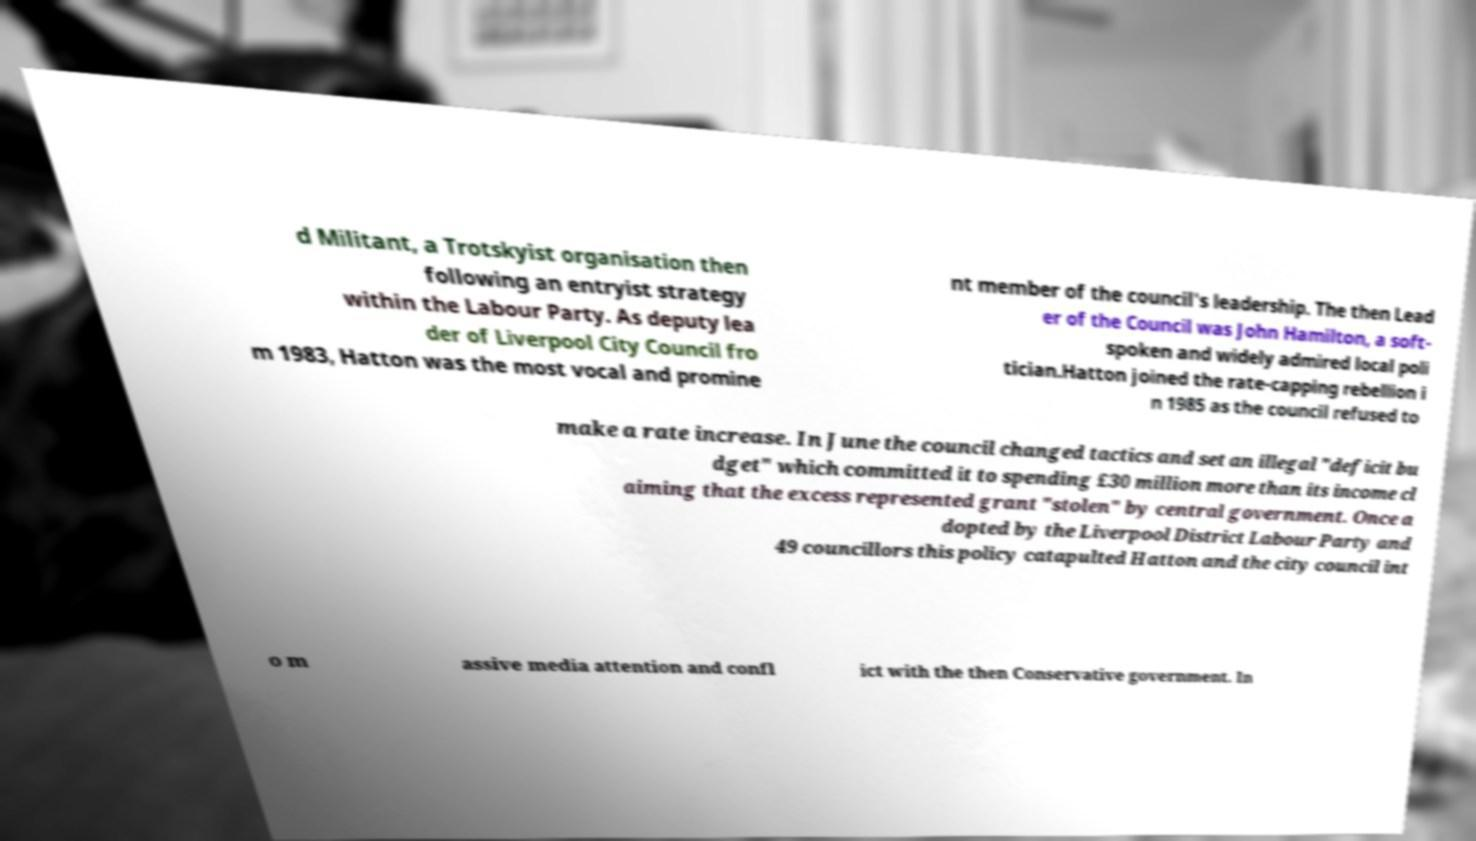Can you accurately transcribe the text from the provided image for me? d Militant, a Trotskyist organisation then following an entryist strategy within the Labour Party. As deputy lea der of Liverpool City Council fro m 1983, Hatton was the most vocal and promine nt member of the council's leadership. The then Lead er of the Council was John Hamilton, a soft- spoken and widely admired local poli tician.Hatton joined the rate-capping rebellion i n 1985 as the council refused to make a rate increase. In June the council changed tactics and set an illegal "deficit bu dget" which committed it to spending £30 million more than its income cl aiming that the excess represented grant "stolen" by central government. Once a dopted by the Liverpool District Labour Party and 49 councillors this policy catapulted Hatton and the city council int o m assive media attention and confl ict with the then Conservative government. In 